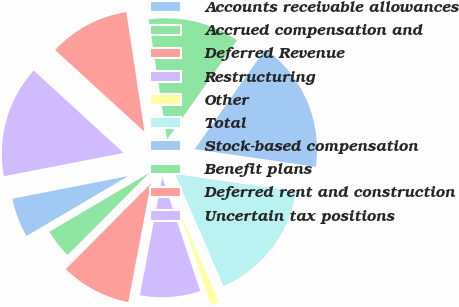Convert chart to OTSL. <chart><loc_0><loc_0><loc_500><loc_500><pie_chart><fcel>Accounts receivable allowances<fcel>Accrued compensation and<fcel>Deferred Revenue<fcel>Restructuring<fcel>Other<fcel>Total<fcel>Stock-based compensation<fcel>Benefit plans<fcel>Deferred rent and construction<fcel>Uncertain tax positions<nl><fcel>5.41%<fcel>4.07%<fcel>9.46%<fcel>8.11%<fcel>1.37%<fcel>16.2%<fcel>17.55%<fcel>12.16%<fcel>10.81%<fcel>14.86%<nl></chart> 